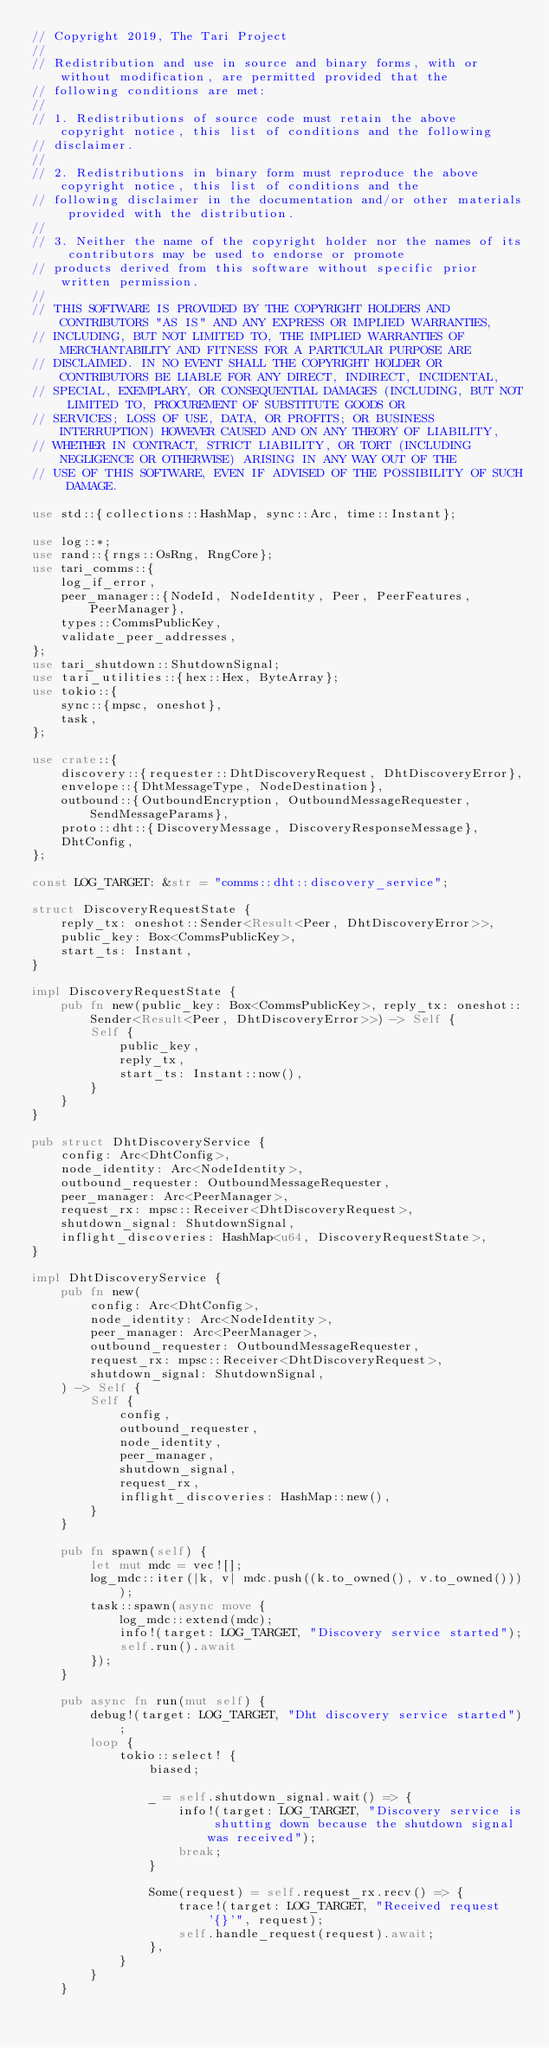Convert code to text. <code><loc_0><loc_0><loc_500><loc_500><_Rust_>// Copyright 2019, The Tari Project
//
// Redistribution and use in source and binary forms, with or without modification, are permitted provided that the
// following conditions are met:
//
// 1. Redistributions of source code must retain the above copyright notice, this list of conditions and the following
// disclaimer.
//
// 2. Redistributions in binary form must reproduce the above copyright notice, this list of conditions and the
// following disclaimer in the documentation and/or other materials provided with the distribution.
//
// 3. Neither the name of the copyright holder nor the names of its contributors may be used to endorse or promote
// products derived from this software without specific prior written permission.
//
// THIS SOFTWARE IS PROVIDED BY THE COPYRIGHT HOLDERS AND CONTRIBUTORS "AS IS" AND ANY EXPRESS OR IMPLIED WARRANTIES,
// INCLUDING, BUT NOT LIMITED TO, THE IMPLIED WARRANTIES OF MERCHANTABILITY AND FITNESS FOR A PARTICULAR PURPOSE ARE
// DISCLAIMED. IN NO EVENT SHALL THE COPYRIGHT HOLDER OR CONTRIBUTORS BE LIABLE FOR ANY DIRECT, INDIRECT, INCIDENTAL,
// SPECIAL, EXEMPLARY, OR CONSEQUENTIAL DAMAGES (INCLUDING, BUT NOT LIMITED TO, PROCUREMENT OF SUBSTITUTE GOODS OR
// SERVICES; LOSS OF USE, DATA, OR PROFITS; OR BUSINESS INTERRUPTION) HOWEVER CAUSED AND ON ANY THEORY OF LIABILITY,
// WHETHER IN CONTRACT, STRICT LIABILITY, OR TORT (INCLUDING NEGLIGENCE OR OTHERWISE) ARISING IN ANY WAY OUT OF THE
// USE OF THIS SOFTWARE, EVEN IF ADVISED OF THE POSSIBILITY OF SUCH DAMAGE.

use std::{collections::HashMap, sync::Arc, time::Instant};

use log::*;
use rand::{rngs::OsRng, RngCore};
use tari_comms::{
    log_if_error,
    peer_manager::{NodeId, NodeIdentity, Peer, PeerFeatures, PeerManager},
    types::CommsPublicKey,
    validate_peer_addresses,
};
use tari_shutdown::ShutdownSignal;
use tari_utilities::{hex::Hex, ByteArray};
use tokio::{
    sync::{mpsc, oneshot},
    task,
};

use crate::{
    discovery::{requester::DhtDiscoveryRequest, DhtDiscoveryError},
    envelope::{DhtMessageType, NodeDestination},
    outbound::{OutboundEncryption, OutboundMessageRequester, SendMessageParams},
    proto::dht::{DiscoveryMessage, DiscoveryResponseMessage},
    DhtConfig,
};

const LOG_TARGET: &str = "comms::dht::discovery_service";

struct DiscoveryRequestState {
    reply_tx: oneshot::Sender<Result<Peer, DhtDiscoveryError>>,
    public_key: Box<CommsPublicKey>,
    start_ts: Instant,
}

impl DiscoveryRequestState {
    pub fn new(public_key: Box<CommsPublicKey>, reply_tx: oneshot::Sender<Result<Peer, DhtDiscoveryError>>) -> Self {
        Self {
            public_key,
            reply_tx,
            start_ts: Instant::now(),
        }
    }
}

pub struct DhtDiscoveryService {
    config: Arc<DhtConfig>,
    node_identity: Arc<NodeIdentity>,
    outbound_requester: OutboundMessageRequester,
    peer_manager: Arc<PeerManager>,
    request_rx: mpsc::Receiver<DhtDiscoveryRequest>,
    shutdown_signal: ShutdownSignal,
    inflight_discoveries: HashMap<u64, DiscoveryRequestState>,
}

impl DhtDiscoveryService {
    pub fn new(
        config: Arc<DhtConfig>,
        node_identity: Arc<NodeIdentity>,
        peer_manager: Arc<PeerManager>,
        outbound_requester: OutboundMessageRequester,
        request_rx: mpsc::Receiver<DhtDiscoveryRequest>,
        shutdown_signal: ShutdownSignal,
    ) -> Self {
        Self {
            config,
            outbound_requester,
            node_identity,
            peer_manager,
            shutdown_signal,
            request_rx,
            inflight_discoveries: HashMap::new(),
        }
    }

    pub fn spawn(self) {
        let mut mdc = vec![];
        log_mdc::iter(|k, v| mdc.push((k.to_owned(), v.to_owned())));
        task::spawn(async move {
            log_mdc::extend(mdc);
            info!(target: LOG_TARGET, "Discovery service started");
            self.run().await
        });
    }

    pub async fn run(mut self) {
        debug!(target: LOG_TARGET, "Dht discovery service started");
        loop {
            tokio::select! {
                biased;

                _ = self.shutdown_signal.wait() => {
                    info!(target: LOG_TARGET, "Discovery service is shutting down because the shutdown signal was received");
                    break;
                }

                Some(request) = self.request_rx.recv() => {
                    trace!(target: LOG_TARGET, "Received request '{}'", request);
                    self.handle_request(request).await;
                },
            }
        }
    }
</code> 